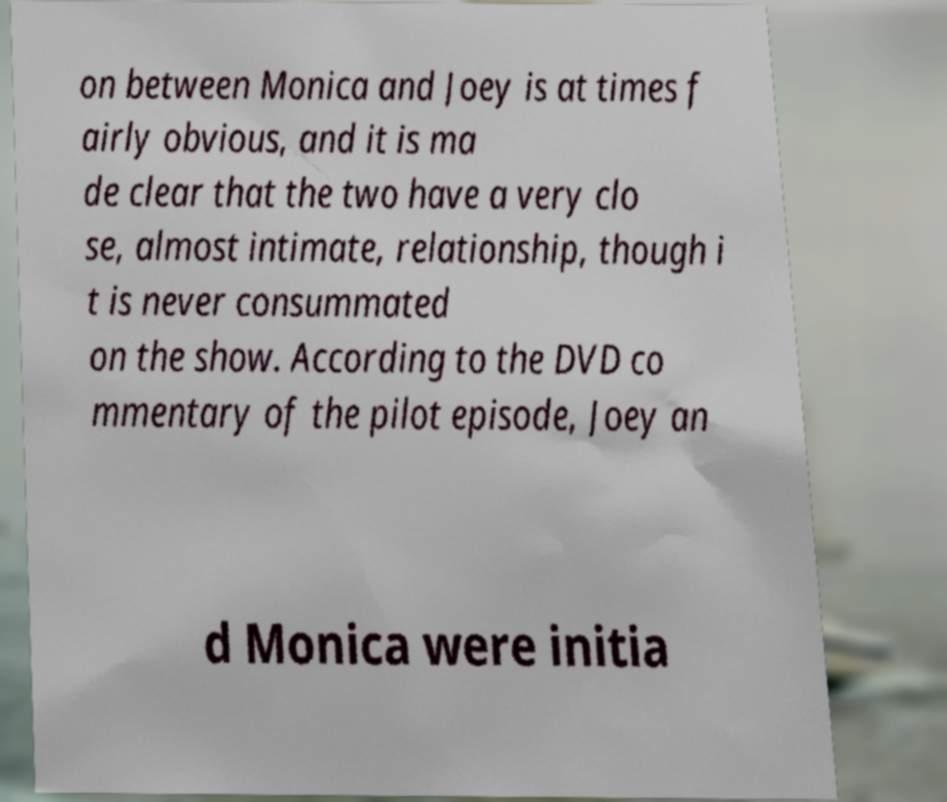Can you accurately transcribe the text from the provided image for me? on between Monica and Joey is at times f airly obvious, and it is ma de clear that the two have a very clo se, almost intimate, relationship, though i t is never consummated on the show. According to the DVD co mmentary of the pilot episode, Joey an d Monica were initia 